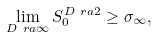Convert formula to latex. <formula><loc_0><loc_0><loc_500><loc_500>\lim _ { D \ r a \infty } S _ { 0 } ^ { D \ r a 2 } \geq \sigma _ { \infty } ,</formula> 